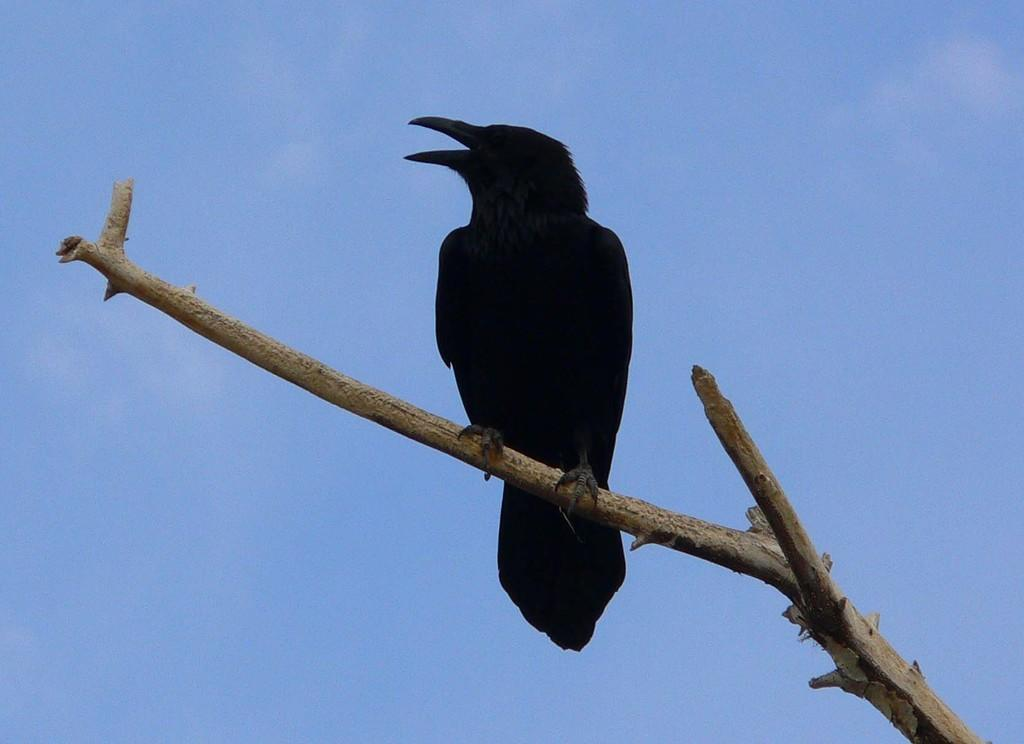What type of animal is present in the image? There is a bird in the image. Where is the bird located in the image? The bird is on a branch. What can be seen in the background of the image? The sky is visible in the background of the image. What type of organization is the bird attempting to join in the image? There is no indication in the image that the bird is attempting to join any organization. Is the bird eating popcorn in the image? There is no popcorn present in the image. 